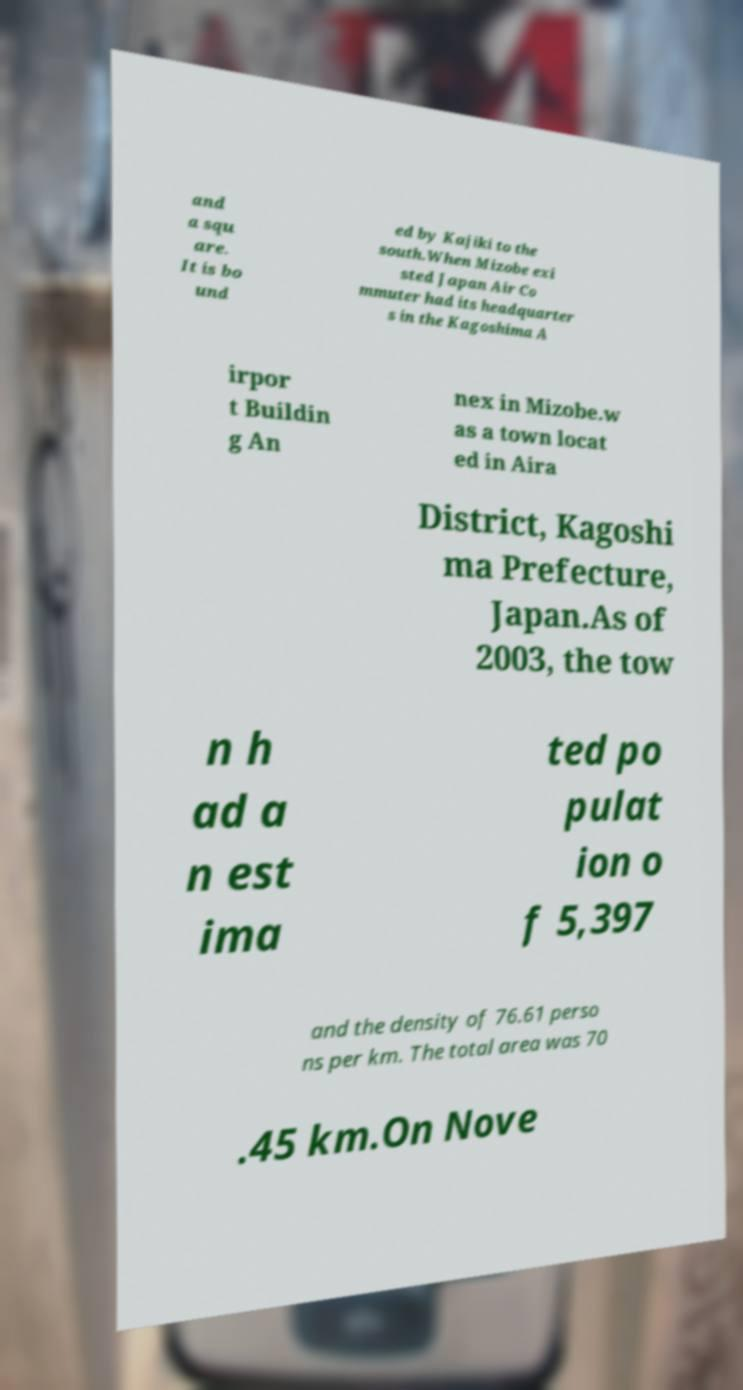Could you extract and type out the text from this image? and a squ are. It is bo und ed by Kajiki to the south.When Mizobe exi sted Japan Air Co mmuter had its headquarter s in the Kagoshima A irpor t Buildin g An nex in Mizobe.w as a town locat ed in Aira District, Kagoshi ma Prefecture, Japan.As of 2003, the tow n h ad a n est ima ted po pulat ion o f 5,397 and the density of 76.61 perso ns per km. The total area was 70 .45 km.On Nove 